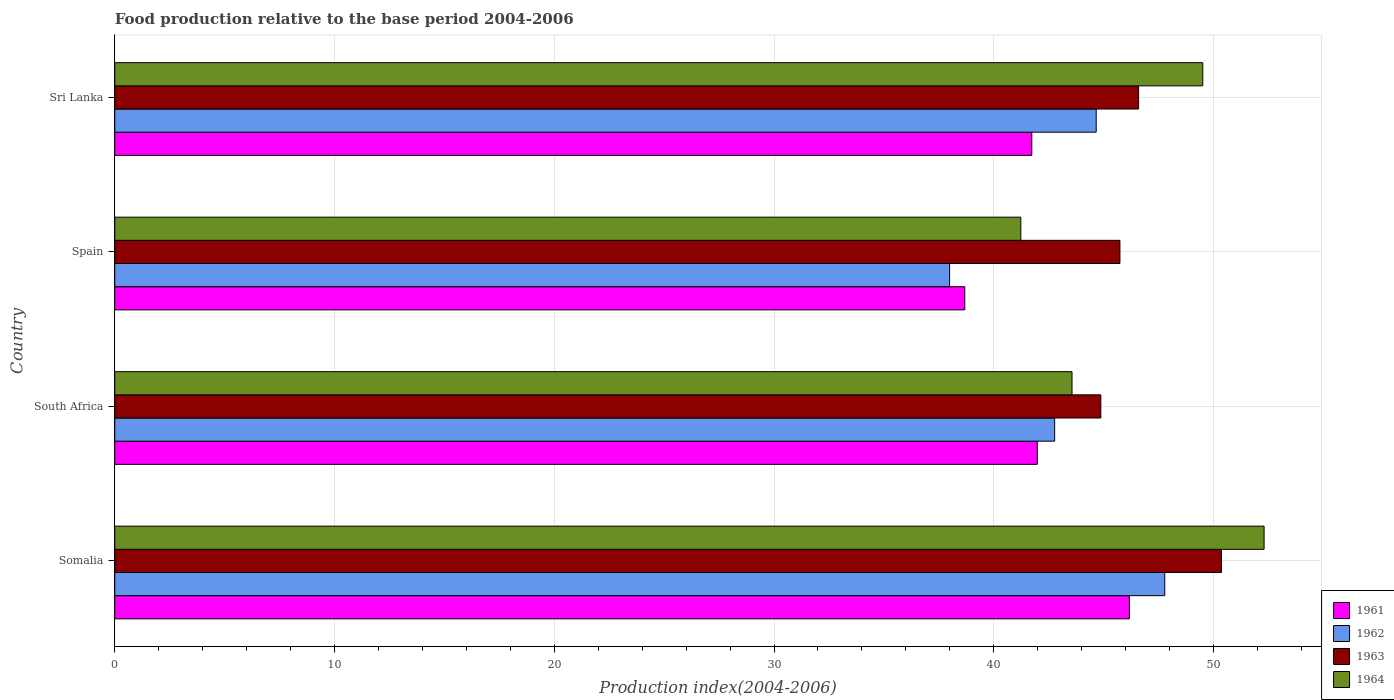How many groups of bars are there?
Keep it short and to the point. 4. Are the number of bars per tick equal to the number of legend labels?
Keep it short and to the point. Yes. Are the number of bars on each tick of the Y-axis equal?
Provide a short and direct response. Yes. How many bars are there on the 2nd tick from the bottom?
Make the answer very short. 4. What is the label of the 4th group of bars from the top?
Offer a terse response. Somalia. In how many cases, is the number of bars for a given country not equal to the number of legend labels?
Your answer should be compact. 0. What is the food production index in 1962 in Sri Lanka?
Your answer should be compact. 44.66. Across all countries, what is the maximum food production index in 1962?
Your answer should be compact. 47.78. Across all countries, what is the minimum food production index in 1962?
Your answer should be compact. 37.99. In which country was the food production index in 1964 maximum?
Your answer should be very brief. Somalia. In which country was the food production index in 1963 minimum?
Make the answer very short. South Africa. What is the total food production index in 1962 in the graph?
Keep it short and to the point. 173.2. What is the difference between the food production index in 1964 in Somalia and that in South Africa?
Your response must be concise. 8.74. What is the difference between the food production index in 1964 in South Africa and the food production index in 1963 in Spain?
Offer a very short reply. -2.18. What is the average food production index in 1961 per country?
Your response must be concise. 42.14. What is the difference between the food production index in 1963 and food production index in 1962 in South Africa?
Make the answer very short. 2.1. What is the ratio of the food production index in 1963 in Somalia to that in Spain?
Make the answer very short. 1.1. Is the food production index in 1963 in South Africa less than that in Spain?
Your answer should be very brief. Yes. Is the difference between the food production index in 1963 in South Africa and Sri Lanka greater than the difference between the food production index in 1962 in South Africa and Sri Lanka?
Keep it short and to the point. Yes. What is the difference between the highest and the second highest food production index in 1961?
Your response must be concise. 4.19. What is the difference between the highest and the lowest food production index in 1962?
Make the answer very short. 9.79. In how many countries, is the food production index in 1963 greater than the average food production index in 1963 taken over all countries?
Your answer should be compact. 1. Is the sum of the food production index in 1964 in South Africa and Spain greater than the maximum food production index in 1963 across all countries?
Offer a terse response. Yes. What does the 4th bar from the bottom in Spain represents?
Provide a succinct answer. 1964. How many bars are there?
Your response must be concise. 16. How many countries are there in the graph?
Your answer should be very brief. 4. Are the values on the major ticks of X-axis written in scientific E-notation?
Your answer should be compact. No. Does the graph contain any zero values?
Ensure brevity in your answer.  No. Does the graph contain grids?
Provide a succinct answer. Yes. Where does the legend appear in the graph?
Your response must be concise. Bottom right. How many legend labels are there?
Make the answer very short. 4. What is the title of the graph?
Give a very brief answer. Food production relative to the base period 2004-2006. What is the label or title of the X-axis?
Your answer should be very brief. Production index(2004-2006). What is the label or title of the Y-axis?
Provide a short and direct response. Country. What is the Production index(2004-2006) in 1961 in Somalia?
Give a very brief answer. 46.17. What is the Production index(2004-2006) of 1962 in Somalia?
Provide a short and direct response. 47.78. What is the Production index(2004-2006) of 1963 in Somalia?
Ensure brevity in your answer.  50.36. What is the Production index(2004-2006) of 1964 in Somalia?
Your answer should be compact. 52.3. What is the Production index(2004-2006) in 1961 in South Africa?
Keep it short and to the point. 41.98. What is the Production index(2004-2006) in 1962 in South Africa?
Your answer should be very brief. 42.77. What is the Production index(2004-2006) of 1963 in South Africa?
Your answer should be very brief. 44.87. What is the Production index(2004-2006) of 1964 in South Africa?
Offer a very short reply. 43.56. What is the Production index(2004-2006) in 1961 in Spain?
Your answer should be very brief. 38.68. What is the Production index(2004-2006) in 1962 in Spain?
Offer a very short reply. 37.99. What is the Production index(2004-2006) in 1963 in Spain?
Make the answer very short. 45.74. What is the Production index(2004-2006) in 1964 in Spain?
Ensure brevity in your answer.  41.23. What is the Production index(2004-2006) of 1961 in Sri Lanka?
Offer a terse response. 41.73. What is the Production index(2004-2006) in 1962 in Sri Lanka?
Ensure brevity in your answer.  44.66. What is the Production index(2004-2006) in 1963 in Sri Lanka?
Your response must be concise. 46.59. What is the Production index(2004-2006) of 1964 in Sri Lanka?
Keep it short and to the point. 49.51. Across all countries, what is the maximum Production index(2004-2006) of 1961?
Offer a terse response. 46.17. Across all countries, what is the maximum Production index(2004-2006) in 1962?
Make the answer very short. 47.78. Across all countries, what is the maximum Production index(2004-2006) of 1963?
Your response must be concise. 50.36. Across all countries, what is the maximum Production index(2004-2006) of 1964?
Offer a terse response. 52.3. Across all countries, what is the minimum Production index(2004-2006) of 1961?
Provide a short and direct response. 38.68. Across all countries, what is the minimum Production index(2004-2006) in 1962?
Your answer should be very brief. 37.99. Across all countries, what is the minimum Production index(2004-2006) of 1963?
Provide a succinct answer. 44.87. Across all countries, what is the minimum Production index(2004-2006) in 1964?
Offer a very short reply. 41.23. What is the total Production index(2004-2006) of 1961 in the graph?
Your answer should be compact. 168.56. What is the total Production index(2004-2006) in 1962 in the graph?
Make the answer very short. 173.2. What is the total Production index(2004-2006) in 1963 in the graph?
Your answer should be compact. 187.56. What is the total Production index(2004-2006) in 1964 in the graph?
Your response must be concise. 186.6. What is the difference between the Production index(2004-2006) in 1961 in Somalia and that in South Africa?
Ensure brevity in your answer.  4.19. What is the difference between the Production index(2004-2006) of 1962 in Somalia and that in South Africa?
Ensure brevity in your answer.  5.01. What is the difference between the Production index(2004-2006) in 1963 in Somalia and that in South Africa?
Give a very brief answer. 5.49. What is the difference between the Production index(2004-2006) in 1964 in Somalia and that in South Africa?
Make the answer very short. 8.74. What is the difference between the Production index(2004-2006) of 1961 in Somalia and that in Spain?
Ensure brevity in your answer.  7.49. What is the difference between the Production index(2004-2006) of 1962 in Somalia and that in Spain?
Offer a terse response. 9.79. What is the difference between the Production index(2004-2006) of 1963 in Somalia and that in Spain?
Offer a very short reply. 4.62. What is the difference between the Production index(2004-2006) of 1964 in Somalia and that in Spain?
Your answer should be compact. 11.07. What is the difference between the Production index(2004-2006) of 1961 in Somalia and that in Sri Lanka?
Keep it short and to the point. 4.44. What is the difference between the Production index(2004-2006) in 1962 in Somalia and that in Sri Lanka?
Offer a terse response. 3.12. What is the difference between the Production index(2004-2006) in 1963 in Somalia and that in Sri Lanka?
Ensure brevity in your answer.  3.77. What is the difference between the Production index(2004-2006) of 1964 in Somalia and that in Sri Lanka?
Offer a terse response. 2.79. What is the difference between the Production index(2004-2006) in 1961 in South Africa and that in Spain?
Ensure brevity in your answer.  3.3. What is the difference between the Production index(2004-2006) in 1962 in South Africa and that in Spain?
Make the answer very short. 4.78. What is the difference between the Production index(2004-2006) in 1963 in South Africa and that in Spain?
Give a very brief answer. -0.87. What is the difference between the Production index(2004-2006) in 1964 in South Africa and that in Spain?
Make the answer very short. 2.33. What is the difference between the Production index(2004-2006) of 1962 in South Africa and that in Sri Lanka?
Give a very brief answer. -1.89. What is the difference between the Production index(2004-2006) in 1963 in South Africa and that in Sri Lanka?
Give a very brief answer. -1.72. What is the difference between the Production index(2004-2006) of 1964 in South Africa and that in Sri Lanka?
Offer a very short reply. -5.95. What is the difference between the Production index(2004-2006) of 1961 in Spain and that in Sri Lanka?
Make the answer very short. -3.05. What is the difference between the Production index(2004-2006) in 1962 in Spain and that in Sri Lanka?
Offer a terse response. -6.67. What is the difference between the Production index(2004-2006) of 1963 in Spain and that in Sri Lanka?
Give a very brief answer. -0.85. What is the difference between the Production index(2004-2006) in 1964 in Spain and that in Sri Lanka?
Provide a short and direct response. -8.28. What is the difference between the Production index(2004-2006) in 1961 in Somalia and the Production index(2004-2006) in 1964 in South Africa?
Your response must be concise. 2.61. What is the difference between the Production index(2004-2006) of 1962 in Somalia and the Production index(2004-2006) of 1963 in South Africa?
Provide a short and direct response. 2.91. What is the difference between the Production index(2004-2006) of 1962 in Somalia and the Production index(2004-2006) of 1964 in South Africa?
Give a very brief answer. 4.22. What is the difference between the Production index(2004-2006) of 1961 in Somalia and the Production index(2004-2006) of 1962 in Spain?
Offer a very short reply. 8.18. What is the difference between the Production index(2004-2006) in 1961 in Somalia and the Production index(2004-2006) in 1963 in Spain?
Offer a very short reply. 0.43. What is the difference between the Production index(2004-2006) of 1961 in Somalia and the Production index(2004-2006) of 1964 in Spain?
Provide a succinct answer. 4.94. What is the difference between the Production index(2004-2006) in 1962 in Somalia and the Production index(2004-2006) in 1963 in Spain?
Your answer should be very brief. 2.04. What is the difference between the Production index(2004-2006) of 1962 in Somalia and the Production index(2004-2006) of 1964 in Spain?
Offer a terse response. 6.55. What is the difference between the Production index(2004-2006) in 1963 in Somalia and the Production index(2004-2006) in 1964 in Spain?
Your response must be concise. 9.13. What is the difference between the Production index(2004-2006) of 1961 in Somalia and the Production index(2004-2006) of 1962 in Sri Lanka?
Your answer should be compact. 1.51. What is the difference between the Production index(2004-2006) of 1961 in Somalia and the Production index(2004-2006) of 1963 in Sri Lanka?
Your answer should be compact. -0.42. What is the difference between the Production index(2004-2006) in 1961 in Somalia and the Production index(2004-2006) in 1964 in Sri Lanka?
Ensure brevity in your answer.  -3.34. What is the difference between the Production index(2004-2006) in 1962 in Somalia and the Production index(2004-2006) in 1963 in Sri Lanka?
Provide a succinct answer. 1.19. What is the difference between the Production index(2004-2006) in 1962 in Somalia and the Production index(2004-2006) in 1964 in Sri Lanka?
Offer a very short reply. -1.73. What is the difference between the Production index(2004-2006) of 1961 in South Africa and the Production index(2004-2006) of 1962 in Spain?
Give a very brief answer. 3.99. What is the difference between the Production index(2004-2006) in 1961 in South Africa and the Production index(2004-2006) in 1963 in Spain?
Offer a terse response. -3.76. What is the difference between the Production index(2004-2006) in 1961 in South Africa and the Production index(2004-2006) in 1964 in Spain?
Ensure brevity in your answer.  0.75. What is the difference between the Production index(2004-2006) in 1962 in South Africa and the Production index(2004-2006) in 1963 in Spain?
Your answer should be compact. -2.97. What is the difference between the Production index(2004-2006) of 1962 in South Africa and the Production index(2004-2006) of 1964 in Spain?
Give a very brief answer. 1.54. What is the difference between the Production index(2004-2006) of 1963 in South Africa and the Production index(2004-2006) of 1964 in Spain?
Offer a very short reply. 3.64. What is the difference between the Production index(2004-2006) in 1961 in South Africa and the Production index(2004-2006) in 1962 in Sri Lanka?
Keep it short and to the point. -2.68. What is the difference between the Production index(2004-2006) in 1961 in South Africa and the Production index(2004-2006) in 1963 in Sri Lanka?
Your answer should be compact. -4.61. What is the difference between the Production index(2004-2006) in 1961 in South Africa and the Production index(2004-2006) in 1964 in Sri Lanka?
Make the answer very short. -7.53. What is the difference between the Production index(2004-2006) of 1962 in South Africa and the Production index(2004-2006) of 1963 in Sri Lanka?
Your answer should be very brief. -3.82. What is the difference between the Production index(2004-2006) of 1962 in South Africa and the Production index(2004-2006) of 1964 in Sri Lanka?
Provide a succinct answer. -6.74. What is the difference between the Production index(2004-2006) of 1963 in South Africa and the Production index(2004-2006) of 1964 in Sri Lanka?
Offer a very short reply. -4.64. What is the difference between the Production index(2004-2006) in 1961 in Spain and the Production index(2004-2006) in 1962 in Sri Lanka?
Offer a terse response. -5.98. What is the difference between the Production index(2004-2006) of 1961 in Spain and the Production index(2004-2006) of 1963 in Sri Lanka?
Your response must be concise. -7.91. What is the difference between the Production index(2004-2006) in 1961 in Spain and the Production index(2004-2006) in 1964 in Sri Lanka?
Give a very brief answer. -10.83. What is the difference between the Production index(2004-2006) of 1962 in Spain and the Production index(2004-2006) of 1963 in Sri Lanka?
Provide a succinct answer. -8.6. What is the difference between the Production index(2004-2006) in 1962 in Spain and the Production index(2004-2006) in 1964 in Sri Lanka?
Give a very brief answer. -11.52. What is the difference between the Production index(2004-2006) in 1963 in Spain and the Production index(2004-2006) in 1964 in Sri Lanka?
Keep it short and to the point. -3.77. What is the average Production index(2004-2006) in 1961 per country?
Make the answer very short. 42.14. What is the average Production index(2004-2006) in 1962 per country?
Provide a succinct answer. 43.3. What is the average Production index(2004-2006) of 1963 per country?
Give a very brief answer. 46.89. What is the average Production index(2004-2006) in 1964 per country?
Offer a very short reply. 46.65. What is the difference between the Production index(2004-2006) of 1961 and Production index(2004-2006) of 1962 in Somalia?
Provide a succinct answer. -1.61. What is the difference between the Production index(2004-2006) of 1961 and Production index(2004-2006) of 1963 in Somalia?
Ensure brevity in your answer.  -4.19. What is the difference between the Production index(2004-2006) of 1961 and Production index(2004-2006) of 1964 in Somalia?
Keep it short and to the point. -6.13. What is the difference between the Production index(2004-2006) of 1962 and Production index(2004-2006) of 1963 in Somalia?
Give a very brief answer. -2.58. What is the difference between the Production index(2004-2006) of 1962 and Production index(2004-2006) of 1964 in Somalia?
Provide a short and direct response. -4.52. What is the difference between the Production index(2004-2006) of 1963 and Production index(2004-2006) of 1964 in Somalia?
Ensure brevity in your answer.  -1.94. What is the difference between the Production index(2004-2006) of 1961 and Production index(2004-2006) of 1962 in South Africa?
Your response must be concise. -0.79. What is the difference between the Production index(2004-2006) of 1961 and Production index(2004-2006) of 1963 in South Africa?
Keep it short and to the point. -2.89. What is the difference between the Production index(2004-2006) of 1961 and Production index(2004-2006) of 1964 in South Africa?
Your answer should be compact. -1.58. What is the difference between the Production index(2004-2006) in 1962 and Production index(2004-2006) in 1964 in South Africa?
Give a very brief answer. -0.79. What is the difference between the Production index(2004-2006) in 1963 and Production index(2004-2006) in 1964 in South Africa?
Offer a very short reply. 1.31. What is the difference between the Production index(2004-2006) of 1961 and Production index(2004-2006) of 1962 in Spain?
Provide a succinct answer. 0.69. What is the difference between the Production index(2004-2006) in 1961 and Production index(2004-2006) in 1963 in Spain?
Keep it short and to the point. -7.06. What is the difference between the Production index(2004-2006) in 1961 and Production index(2004-2006) in 1964 in Spain?
Give a very brief answer. -2.55. What is the difference between the Production index(2004-2006) in 1962 and Production index(2004-2006) in 1963 in Spain?
Give a very brief answer. -7.75. What is the difference between the Production index(2004-2006) in 1962 and Production index(2004-2006) in 1964 in Spain?
Make the answer very short. -3.24. What is the difference between the Production index(2004-2006) of 1963 and Production index(2004-2006) of 1964 in Spain?
Your answer should be very brief. 4.51. What is the difference between the Production index(2004-2006) in 1961 and Production index(2004-2006) in 1962 in Sri Lanka?
Ensure brevity in your answer.  -2.93. What is the difference between the Production index(2004-2006) in 1961 and Production index(2004-2006) in 1963 in Sri Lanka?
Offer a terse response. -4.86. What is the difference between the Production index(2004-2006) of 1961 and Production index(2004-2006) of 1964 in Sri Lanka?
Offer a terse response. -7.78. What is the difference between the Production index(2004-2006) in 1962 and Production index(2004-2006) in 1963 in Sri Lanka?
Keep it short and to the point. -1.93. What is the difference between the Production index(2004-2006) in 1962 and Production index(2004-2006) in 1964 in Sri Lanka?
Give a very brief answer. -4.85. What is the difference between the Production index(2004-2006) in 1963 and Production index(2004-2006) in 1964 in Sri Lanka?
Keep it short and to the point. -2.92. What is the ratio of the Production index(2004-2006) in 1961 in Somalia to that in South Africa?
Offer a very short reply. 1.1. What is the ratio of the Production index(2004-2006) of 1962 in Somalia to that in South Africa?
Offer a terse response. 1.12. What is the ratio of the Production index(2004-2006) of 1963 in Somalia to that in South Africa?
Keep it short and to the point. 1.12. What is the ratio of the Production index(2004-2006) of 1964 in Somalia to that in South Africa?
Provide a succinct answer. 1.2. What is the ratio of the Production index(2004-2006) in 1961 in Somalia to that in Spain?
Offer a very short reply. 1.19. What is the ratio of the Production index(2004-2006) in 1962 in Somalia to that in Spain?
Offer a very short reply. 1.26. What is the ratio of the Production index(2004-2006) of 1963 in Somalia to that in Spain?
Keep it short and to the point. 1.1. What is the ratio of the Production index(2004-2006) of 1964 in Somalia to that in Spain?
Offer a terse response. 1.27. What is the ratio of the Production index(2004-2006) in 1961 in Somalia to that in Sri Lanka?
Your answer should be compact. 1.11. What is the ratio of the Production index(2004-2006) in 1962 in Somalia to that in Sri Lanka?
Make the answer very short. 1.07. What is the ratio of the Production index(2004-2006) in 1963 in Somalia to that in Sri Lanka?
Offer a terse response. 1.08. What is the ratio of the Production index(2004-2006) in 1964 in Somalia to that in Sri Lanka?
Offer a terse response. 1.06. What is the ratio of the Production index(2004-2006) of 1961 in South Africa to that in Spain?
Provide a short and direct response. 1.09. What is the ratio of the Production index(2004-2006) of 1962 in South Africa to that in Spain?
Offer a very short reply. 1.13. What is the ratio of the Production index(2004-2006) of 1963 in South Africa to that in Spain?
Offer a terse response. 0.98. What is the ratio of the Production index(2004-2006) in 1964 in South Africa to that in Spain?
Make the answer very short. 1.06. What is the ratio of the Production index(2004-2006) of 1962 in South Africa to that in Sri Lanka?
Provide a short and direct response. 0.96. What is the ratio of the Production index(2004-2006) in 1963 in South Africa to that in Sri Lanka?
Offer a terse response. 0.96. What is the ratio of the Production index(2004-2006) of 1964 in South Africa to that in Sri Lanka?
Provide a short and direct response. 0.88. What is the ratio of the Production index(2004-2006) in 1961 in Spain to that in Sri Lanka?
Ensure brevity in your answer.  0.93. What is the ratio of the Production index(2004-2006) of 1962 in Spain to that in Sri Lanka?
Your answer should be very brief. 0.85. What is the ratio of the Production index(2004-2006) in 1963 in Spain to that in Sri Lanka?
Your answer should be compact. 0.98. What is the ratio of the Production index(2004-2006) in 1964 in Spain to that in Sri Lanka?
Offer a very short reply. 0.83. What is the difference between the highest and the second highest Production index(2004-2006) of 1961?
Give a very brief answer. 4.19. What is the difference between the highest and the second highest Production index(2004-2006) of 1962?
Offer a terse response. 3.12. What is the difference between the highest and the second highest Production index(2004-2006) in 1963?
Provide a short and direct response. 3.77. What is the difference between the highest and the second highest Production index(2004-2006) in 1964?
Your answer should be very brief. 2.79. What is the difference between the highest and the lowest Production index(2004-2006) in 1961?
Your response must be concise. 7.49. What is the difference between the highest and the lowest Production index(2004-2006) of 1962?
Give a very brief answer. 9.79. What is the difference between the highest and the lowest Production index(2004-2006) of 1963?
Your response must be concise. 5.49. What is the difference between the highest and the lowest Production index(2004-2006) in 1964?
Your answer should be very brief. 11.07. 